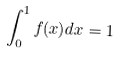<formula> <loc_0><loc_0><loc_500><loc_500>\int _ { 0 } ^ { 1 } f ( x ) d x = 1</formula> 